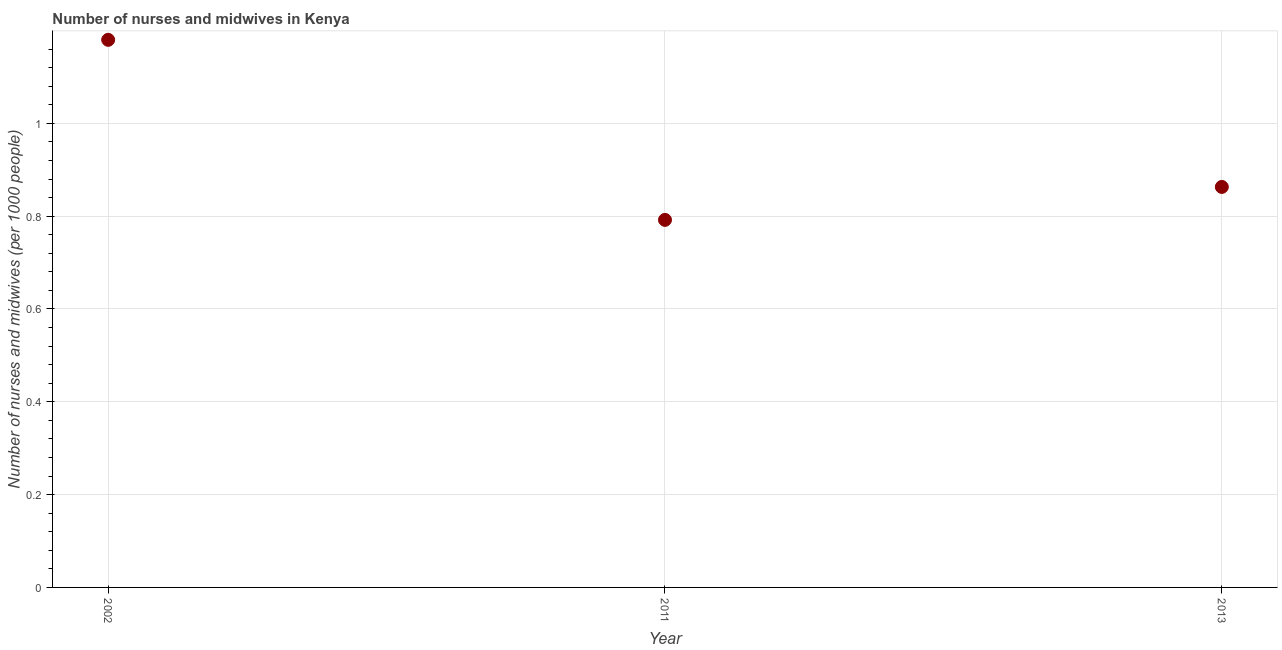What is the number of nurses and midwives in 2011?
Give a very brief answer. 0.79. Across all years, what is the maximum number of nurses and midwives?
Your answer should be very brief. 1.18. Across all years, what is the minimum number of nurses and midwives?
Offer a terse response. 0.79. What is the sum of the number of nurses and midwives?
Your answer should be compact. 2.83. What is the difference between the number of nurses and midwives in 2002 and 2013?
Make the answer very short. 0.32. What is the average number of nurses and midwives per year?
Offer a terse response. 0.94. What is the median number of nurses and midwives?
Your response must be concise. 0.86. In how many years, is the number of nurses and midwives greater than 0.28 ?
Your answer should be compact. 3. Do a majority of the years between 2011 and 2002 (inclusive) have number of nurses and midwives greater than 0.68 ?
Your answer should be compact. No. What is the ratio of the number of nurses and midwives in 2002 to that in 2011?
Your answer should be compact. 1.49. Is the number of nurses and midwives in 2011 less than that in 2013?
Offer a very short reply. Yes. Is the difference between the number of nurses and midwives in 2002 and 2013 greater than the difference between any two years?
Provide a succinct answer. No. What is the difference between the highest and the second highest number of nurses and midwives?
Offer a terse response. 0.32. Is the sum of the number of nurses and midwives in 2002 and 2011 greater than the maximum number of nurses and midwives across all years?
Your response must be concise. Yes. What is the difference between the highest and the lowest number of nurses and midwives?
Make the answer very short. 0.39. Does the number of nurses and midwives monotonically increase over the years?
Give a very brief answer. No. How many dotlines are there?
Make the answer very short. 1. How many years are there in the graph?
Your response must be concise. 3. What is the difference between two consecutive major ticks on the Y-axis?
Keep it short and to the point. 0.2. Does the graph contain any zero values?
Your answer should be compact. No. Does the graph contain grids?
Your response must be concise. Yes. What is the title of the graph?
Offer a very short reply. Number of nurses and midwives in Kenya. What is the label or title of the X-axis?
Make the answer very short. Year. What is the label or title of the Y-axis?
Offer a very short reply. Number of nurses and midwives (per 1000 people). What is the Number of nurses and midwives (per 1000 people) in 2002?
Keep it short and to the point. 1.18. What is the Number of nurses and midwives (per 1000 people) in 2011?
Offer a terse response. 0.79. What is the Number of nurses and midwives (per 1000 people) in 2013?
Provide a succinct answer. 0.86. What is the difference between the Number of nurses and midwives (per 1000 people) in 2002 and 2011?
Keep it short and to the point. 0.39. What is the difference between the Number of nurses and midwives (per 1000 people) in 2002 and 2013?
Your response must be concise. 0.32. What is the difference between the Number of nurses and midwives (per 1000 people) in 2011 and 2013?
Provide a succinct answer. -0.07. What is the ratio of the Number of nurses and midwives (per 1000 people) in 2002 to that in 2011?
Offer a terse response. 1.49. What is the ratio of the Number of nurses and midwives (per 1000 people) in 2002 to that in 2013?
Provide a short and direct response. 1.37. What is the ratio of the Number of nurses and midwives (per 1000 people) in 2011 to that in 2013?
Your answer should be very brief. 0.92. 